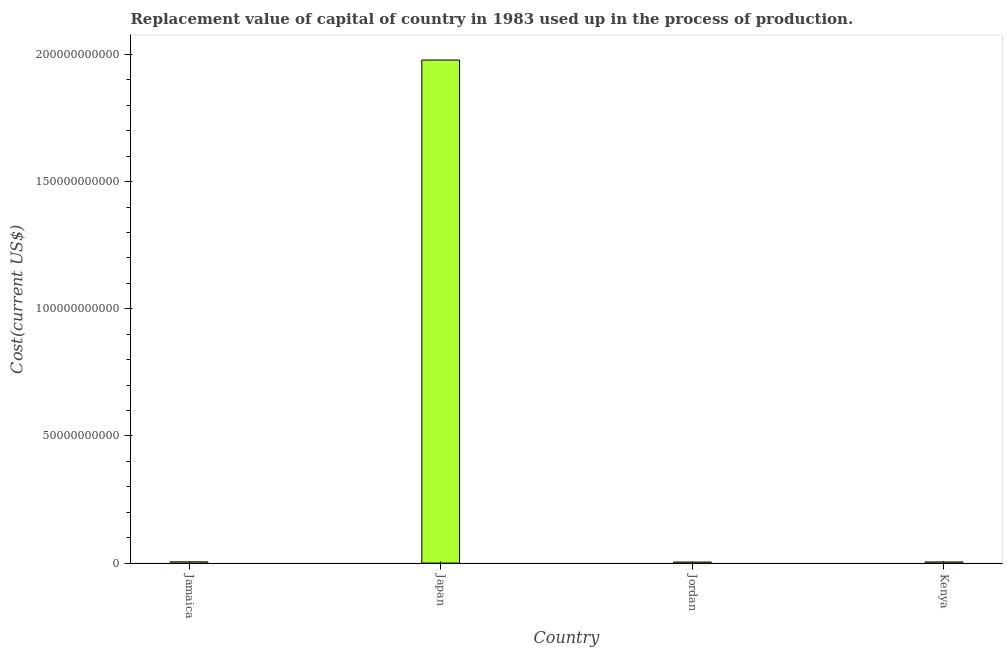What is the title of the graph?
Offer a very short reply. Replacement value of capital of country in 1983 used up in the process of production. What is the label or title of the Y-axis?
Offer a terse response. Cost(current US$). What is the consumption of fixed capital in Jamaica?
Provide a short and direct response. 4.95e+08. Across all countries, what is the maximum consumption of fixed capital?
Make the answer very short. 1.98e+11. Across all countries, what is the minimum consumption of fixed capital?
Keep it short and to the point. 4.11e+08. In which country was the consumption of fixed capital maximum?
Your response must be concise. Japan. In which country was the consumption of fixed capital minimum?
Provide a short and direct response. Jordan. What is the sum of the consumption of fixed capital?
Your answer should be compact. 1.99e+11. What is the difference between the consumption of fixed capital in Jamaica and Kenya?
Offer a terse response. 4.69e+07. What is the average consumption of fixed capital per country?
Your response must be concise. 4.98e+1. What is the median consumption of fixed capital?
Your answer should be very brief. 4.71e+08. In how many countries, is the consumption of fixed capital greater than 50000000000 US$?
Give a very brief answer. 1. What is the ratio of the consumption of fixed capital in Japan to that in Kenya?
Make the answer very short. 441.69. Is the consumption of fixed capital in Jamaica less than that in Japan?
Keep it short and to the point. Yes. Is the difference between the consumption of fixed capital in Jordan and Kenya greater than the difference between any two countries?
Offer a terse response. No. What is the difference between the highest and the second highest consumption of fixed capital?
Ensure brevity in your answer.  1.97e+11. Is the sum of the consumption of fixed capital in Japan and Kenya greater than the maximum consumption of fixed capital across all countries?
Keep it short and to the point. Yes. What is the difference between the highest and the lowest consumption of fixed capital?
Offer a very short reply. 1.97e+11. In how many countries, is the consumption of fixed capital greater than the average consumption of fixed capital taken over all countries?
Your answer should be compact. 1. How many bars are there?
Give a very brief answer. 4. Are all the bars in the graph horizontal?
Offer a terse response. No. How many countries are there in the graph?
Keep it short and to the point. 4. Are the values on the major ticks of Y-axis written in scientific E-notation?
Make the answer very short. No. What is the Cost(current US$) in Jamaica?
Your answer should be compact. 4.95e+08. What is the Cost(current US$) in Japan?
Offer a terse response. 1.98e+11. What is the Cost(current US$) in Jordan?
Your answer should be very brief. 4.11e+08. What is the Cost(current US$) of Kenya?
Provide a short and direct response. 4.48e+08. What is the difference between the Cost(current US$) in Jamaica and Japan?
Offer a terse response. -1.97e+11. What is the difference between the Cost(current US$) in Jamaica and Jordan?
Give a very brief answer. 8.42e+07. What is the difference between the Cost(current US$) in Jamaica and Kenya?
Keep it short and to the point. 4.69e+07. What is the difference between the Cost(current US$) in Japan and Jordan?
Ensure brevity in your answer.  1.97e+11. What is the difference between the Cost(current US$) in Japan and Kenya?
Provide a succinct answer. 1.97e+11. What is the difference between the Cost(current US$) in Jordan and Kenya?
Offer a terse response. -3.73e+07. What is the ratio of the Cost(current US$) in Jamaica to that in Japan?
Make the answer very short. 0. What is the ratio of the Cost(current US$) in Jamaica to that in Jordan?
Your answer should be very brief. 1.21. What is the ratio of the Cost(current US$) in Jamaica to that in Kenya?
Offer a terse response. 1.1. What is the ratio of the Cost(current US$) in Japan to that in Jordan?
Provide a succinct answer. 481.8. What is the ratio of the Cost(current US$) in Japan to that in Kenya?
Provide a succinct answer. 441.69. What is the ratio of the Cost(current US$) in Jordan to that in Kenya?
Keep it short and to the point. 0.92. 